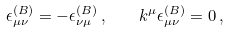Convert formula to latex. <formula><loc_0><loc_0><loc_500><loc_500>\epsilon _ { \mu \nu } ^ { ( B ) } = - \epsilon _ { \nu \mu } ^ { ( B ) } \, , \quad k ^ { \mu } \epsilon _ { \mu \nu } ^ { ( B ) } = 0 \, ,</formula> 